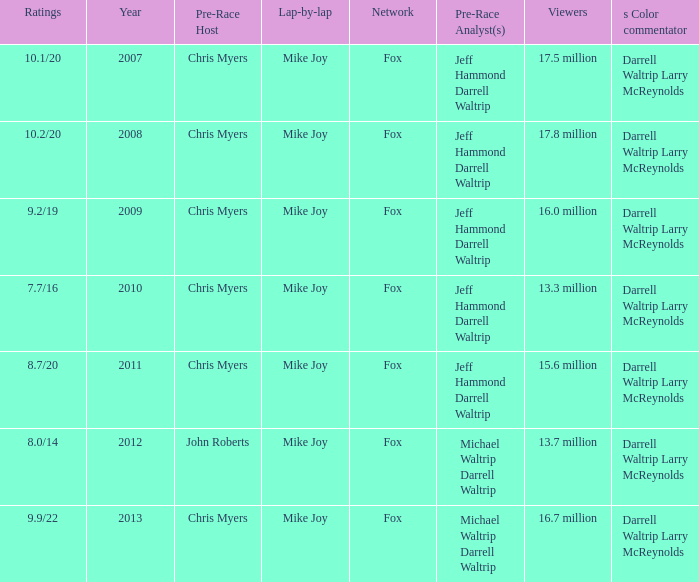Which Network has 17.5 million Viewers? Fox. 